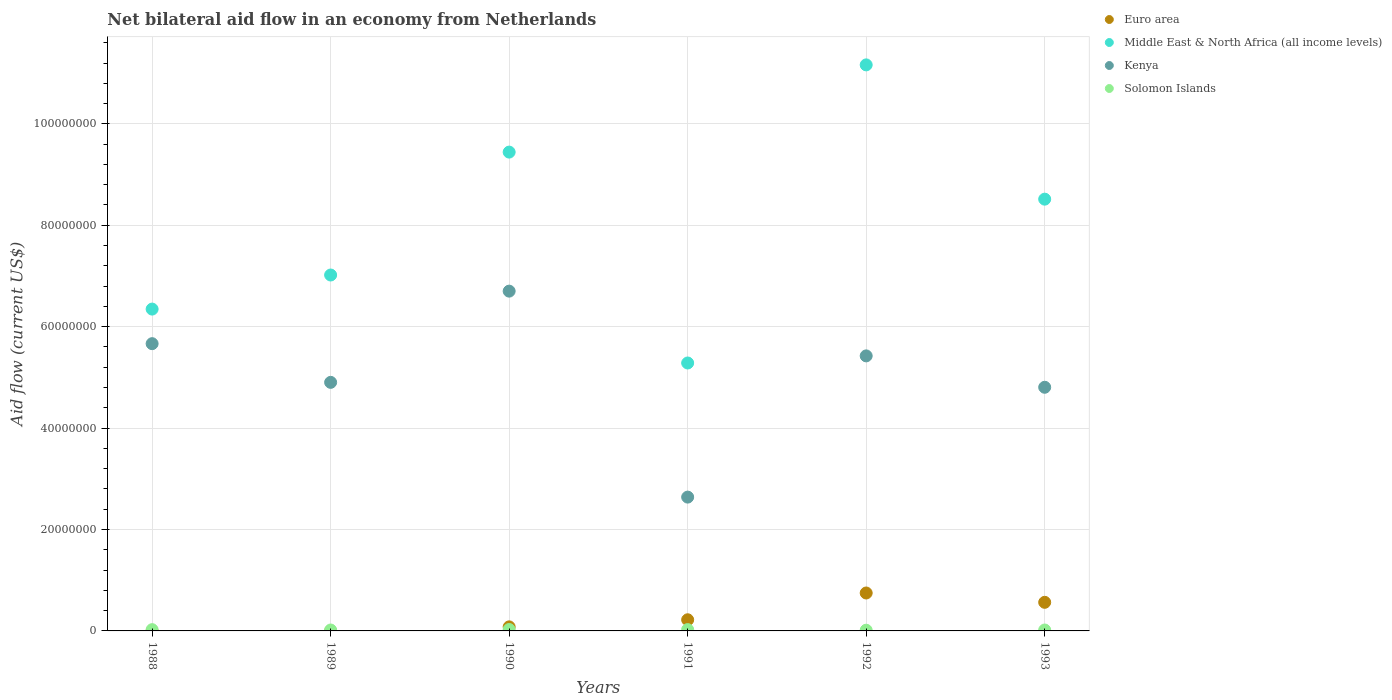How many different coloured dotlines are there?
Keep it short and to the point. 4. Is the number of dotlines equal to the number of legend labels?
Keep it short and to the point. No. What is the net bilateral aid flow in Euro area in 1993?
Provide a succinct answer. 5.64e+06. Across all years, what is the maximum net bilateral aid flow in Euro area?
Provide a short and direct response. 7.48e+06. Across all years, what is the minimum net bilateral aid flow in Kenya?
Give a very brief answer. 2.64e+07. In which year was the net bilateral aid flow in Solomon Islands maximum?
Your answer should be very brief. 1990. What is the total net bilateral aid flow in Kenya in the graph?
Keep it short and to the point. 3.01e+08. What is the difference between the net bilateral aid flow in Solomon Islands in 1990 and that in 1993?
Ensure brevity in your answer.  1.00e+05. What is the difference between the net bilateral aid flow in Kenya in 1992 and the net bilateral aid flow in Euro area in 1989?
Your answer should be compact. 5.42e+07. What is the average net bilateral aid flow in Euro area per year?
Your answer should be compact. 2.69e+06. In the year 1993, what is the difference between the net bilateral aid flow in Middle East & North Africa (all income levels) and net bilateral aid flow in Kenya?
Keep it short and to the point. 3.71e+07. What is the ratio of the net bilateral aid flow in Kenya in 1991 to that in 1993?
Your answer should be very brief. 0.55. Is the net bilateral aid flow in Middle East & North Africa (all income levels) in 1990 less than that in 1992?
Provide a succinct answer. Yes. What is the difference between the highest and the second highest net bilateral aid flow in Solomon Islands?
Make the answer very short. 2.00e+04. What is the difference between the highest and the lowest net bilateral aid flow in Middle East & North Africa (all income levels)?
Your answer should be compact. 5.88e+07. Is the sum of the net bilateral aid flow in Middle East & North Africa (all income levels) in 1989 and 1990 greater than the maximum net bilateral aid flow in Solomon Islands across all years?
Offer a terse response. Yes. Does the net bilateral aid flow in Kenya monotonically increase over the years?
Keep it short and to the point. No. Is the net bilateral aid flow in Kenya strictly greater than the net bilateral aid flow in Solomon Islands over the years?
Your answer should be very brief. Yes. Does the graph contain any zero values?
Your answer should be compact. Yes. Where does the legend appear in the graph?
Your answer should be very brief. Top right. How many legend labels are there?
Your response must be concise. 4. What is the title of the graph?
Your response must be concise. Net bilateral aid flow in an economy from Netherlands. Does "Tunisia" appear as one of the legend labels in the graph?
Keep it short and to the point. No. What is the label or title of the X-axis?
Keep it short and to the point. Years. What is the Aid flow (current US$) of Euro area in 1988?
Your response must be concise. 0. What is the Aid flow (current US$) of Middle East & North Africa (all income levels) in 1988?
Offer a terse response. 6.35e+07. What is the Aid flow (current US$) in Kenya in 1988?
Your response must be concise. 5.66e+07. What is the Aid flow (current US$) in Solomon Islands in 1988?
Keep it short and to the point. 2.50e+05. What is the Aid flow (current US$) in Euro area in 1989?
Provide a succinct answer. 0. What is the Aid flow (current US$) of Middle East & North Africa (all income levels) in 1989?
Give a very brief answer. 7.02e+07. What is the Aid flow (current US$) in Kenya in 1989?
Offer a terse response. 4.90e+07. What is the Aid flow (current US$) in Solomon Islands in 1989?
Provide a short and direct response. 1.80e+05. What is the Aid flow (current US$) of Euro area in 1990?
Your answer should be compact. 8.00e+05. What is the Aid flow (current US$) of Middle East & North Africa (all income levels) in 1990?
Make the answer very short. 9.44e+07. What is the Aid flow (current US$) of Kenya in 1990?
Your response must be concise. 6.70e+07. What is the Aid flow (current US$) in Solomon Islands in 1990?
Provide a succinct answer. 2.80e+05. What is the Aid flow (current US$) of Euro area in 1991?
Ensure brevity in your answer.  2.20e+06. What is the Aid flow (current US$) of Middle East & North Africa (all income levels) in 1991?
Offer a very short reply. 5.28e+07. What is the Aid flow (current US$) of Kenya in 1991?
Your answer should be compact. 2.64e+07. What is the Aid flow (current US$) in Euro area in 1992?
Keep it short and to the point. 7.48e+06. What is the Aid flow (current US$) of Middle East & North Africa (all income levels) in 1992?
Provide a succinct answer. 1.12e+08. What is the Aid flow (current US$) in Kenya in 1992?
Ensure brevity in your answer.  5.42e+07. What is the Aid flow (current US$) of Euro area in 1993?
Make the answer very short. 5.64e+06. What is the Aid flow (current US$) in Middle East & North Africa (all income levels) in 1993?
Offer a terse response. 8.52e+07. What is the Aid flow (current US$) in Kenya in 1993?
Make the answer very short. 4.80e+07. What is the Aid flow (current US$) in Solomon Islands in 1993?
Offer a very short reply. 1.80e+05. Across all years, what is the maximum Aid flow (current US$) of Euro area?
Provide a short and direct response. 7.48e+06. Across all years, what is the maximum Aid flow (current US$) in Middle East & North Africa (all income levels)?
Your answer should be compact. 1.12e+08. Across all years, what is the maximum Aid flow (current US$) of Kenya?
Make the answer very short. 6.70e+07. Across all years, what is the maximum Aid flow (current US$) of Solomon Islands?
Make the answer very short. 2.80e+05. Across all years, what is the minimum Aid flow (current US$) of Euro area?
Ensure brevity in your answer.  0. Across all years, what is the minimum Aid flow (current US$) of Middle East & North Africa (all income levels)?
Keep it short and to the point. 5.28e+07. Across all years, what is the minimum Aid flow (current US$) of Kenya?
Provide a short and direct response. 2.64e+07. Across all years, what is the minimum Aid flow (current US$) in Solomon Islands?
Your response must be concise. 1.40e+05. What is the total Aid flow (current US$) of Euro area in the graph?
Provide a short and direct response. 1.61e+07. What is the total Aid flow (current US$) in Middle East & North Africa (all income levels) in the graph?
Your response must be concise. 4.78e+08. What is the total Aid flow (current US$) in Kenya in the graph?
Give a very brief answer. 3.01e+08. What is the total Aid flow (current US$) of Solomon Islands in the graph?
Offer a very short reply. 1.29e+06. What is the difference between the Aid flow (current US$) in Middle East & North Africa (all income levels) in 1988 and that in 1989?
Your answer should be very brief. -6.72e+06. What is the difference between the Aid flow (current US$) in Kenya in 1988 and that in 1989?
Make the answer very short. 7.63e+06. What is the difference between the Aid flow (current US$) of Solomon Islands in 1988 and that in 1989?
Provide a short and direct response. 7.00e+04. What is the difference between the Aid flow (current US$) of Middle East & North Africa (all income levels) in 1988 and that in 1990?
Give a very brief answer. -3.10e+07. What is the difference between the Aid flow (current US$) of Kenya in 1988 and that in 1990?
Your answer should be very brief. -1.04e+07. What is the difference between the Aid flow (current US$) in Solomon Islands in 1988 and that in 1990?
Ensure brevity in your answer.  -3.00e+04. What is the difference between the Aid flow (current US$) in Middle East & North Africa (all income levels) in 1988 and that in 1991?
Give a very brief answer. 1.06e+07. What is the difference between the Aid flow (current US$) in Kenya in 1988 and that in 1991?
Provide a short and direct response. 3.03e+07. What is the difference between the Aid flow (current US$) of Middle East & North Africa (all income levels) in 1988 and that in 1992?
Offer a terse response. -4.82e+07. What is the difference between the Aid flow (current US$) of Kenya in 1988 and that in 1992?
Your response must be concise. 2.41e+06. What is the difference between the Aid flow (current US$) of Middle East & North Africa (all income levels) in 1988 and that in 1993?
Your answer should be compact. -2.17e+07. What is the difference between the Aid flow (current US$) in Kenya in 1988 and that in 1993?
Keep it short and to the point. 8.60e+06. What is the difference between the Aid flow (current US$) of Middle East & North Africa (all income levels) in 1989 and that in 1990?
Your response must be concise. -2.42e+07. What is the difference between the Aid flow (current US$) in Kenya in 1989 and that in 1990?
Make the answer very short. -1.80e+07. What is the difference between the Aid flow (current US$) in Middle East & North Africa (all income levels) in 1989 and that in 1991?
Provide a short and direct response. 1.74e+07. What is the difference between the Aid flow (current US$) of Kenya in 1989 and that in 1991?
Provide a short and direct response. 2.26e+07. What is the difference between the Aid flow (current US$) in Solomon Islands in 1989 and that in 1991?
Give a very brief answer. -8.00e+04. What is the difference between the Aid flow (current US$) of Middle East & North Africa (all income levels) in 1989 and that in 1992?
Your answer should be compact. -4.14e+07. What is the difference between the Aid flow (current US$) in Kenya in 1989 and that in 1992?
Ensure brevity in your answer.  -5.22e+06. What is the difference between the Aid flow (current US$) in Solomon Islands in 1989 and that in 1992?
Offer a very short reply. 4.00e+04. What is the difference between the Aid flow (current US$) of Middle East & North Africa (all income levels) in 1989 and that in 1993?
Offer a terse response. -1.50e+07. What is the difference between the Aid flow (current US$) in Kenya in 1989 and that in 1993?
Keep it short and to the point. 9.70e+05. What is the difference between the Aid flow (current US$) of Euro area in 1990 and that in 1991?
Offer a terse response. -1.40e+06. What is the difference between the Aid flow (current US$) in Middle East & North Africa (all income levels) in 1990 and that in 1991?
Make the answer very short. 4.16e+07. What is the difference between the Aid flow (current US$) of Kenya in 1990 and that in 1991?
Your answer should be compact. 4.06e+07. What is the difference between the Aid flow (current US$) in Euro area in 1990 and that in 1992?
Keep it short and to the point. -6.68e+06. What is the difference between the Aid flow (current US$) in Middle East & North Africa (all income levels) in 1990 and that in 1992?
Make the answer very short. -1.72e+07. What is the difference between the Aid flow (current US$) of Kenya in 1990 and that in 1992?
Provide a succinct answer. 1.28e+07. What is the difference between the Aid flow (current US$) of Solomon Islands in 1990 and that in 1992?
Ensure brevity in your answer.  1.40e+05. What is the difference between the Aid flow (current US$) in Euro area in 1990 and that in 1993?
Your response must be concise. -4.84e+06. What is the difference between the Aid flow (current US$) in Middle East & North Africa (all income levels) in 1990 and that in 1993?
Your answer should be very brief. 9.28e+06. What is the difference between the Aid flow (current US$) of Kenya in 1990 and that in 1993?
Your response must be concise. 1.90e+07. What is the difference between the Aid flow (current US$) in Solomon Islands in 1990 and that in 1993?
Provide a succinct answer. 1.00e+05. What is the difference between the Aid flow (current US$) of Euro area in 1991 and that in 1992?
Provide a succinct answer. -5.28e+06. What is the difference between the Aid flow (current US$) of Middle East & North Africa (all income levels) in 1991 and that in 1992?
Give a very brief answer. -5.88e+07. What is the difference between the Aid flow (current US$) in Kenya in 1991 and that in 1992?
Make the answer very short. -2.78e+07. What is the difference between the Aid flow (current US$) in Solomon Islands in 1991 and that in 1992?
Offer a terse response. 1.20e+05. What is the difference between the Aid flow (current US$) of Euro area in 1991 and that in 1993?
Keep it short and to the point. -3.44e+06. What is the difference between the Aid flow (current US$) of Middle East & North Africa (all income levels) in 1991 and that in 1993?
Offer a very short reply. -3.23e+07. What is the difference between the Aid flow (current US$) of Kenya in 1991 and that in 1993?
Offer a very short reply. -2.17e+07. What is the difference between the Aid flow (current US$) in Solomon Islands in 1991 and that in 1993?
Your response must be concise. 8.00e+04. What is the difference between the Aid flow (current US$) of Euro area in 1992 and that in 1993?
Give a very brief answer. 1.84e+06. What is the difference between the Aid flow (current US$) of Middle East & North Africa (all income levels) in 1992 and that in 1993?
Provide a short and direct response. 2.65e+07. What is the difference between the Aid flow (current US$) of Kenya in 1992 and that in 1993?
Ensure brevity in your answer.  6.19e+06. What is the difference between the Aid flow (current US$) of Middle East & North Africa (all income levels) in 1988 and the Aid flow (current US$) of Kenya in 1989?
Keep it short and to the point. 1.44e+07. What is the difference between the Aid flow (current US$) in Middle East & North Africa (all income levels) in 1988 and the Aid flow (current US$) in Solomon Islands in 1989?
Your response must be concise. 6.33e+07. What is the difference between the Aid flow (current US$) of Kenya in 1988 and the Aid flow (current US$) of Solomon Islands in 1989?
Your response must be concise. 5.65e+07. What is the difference between the Aid flow (current US$) of Middle East & North Africa (all income levels) in 1988 and the Aid flow (current US$) of Kenya in 1990?
Your answer should be very brief. -3.54e+06. What is the difference between the Aid flow (current US$) of Middle East & North Africa (all income levels) in 1988 and the Aid flow (current US$) of Solomon Islands in 1990?
Make the answer very short. 6.32e+07. What is the difference between the Aid flow (current US$) in Kenya in 1988 and the Aid flow (current US$) in Solomon Islands in 1990?
Provide a short and direct response. 5.64e+07. What is the difference between the Aid flow (current US$) of Middle East & North Africa (all income levels) in 1988 and the Aid flow (current US$) of Kenya in 1991?
Make the answer very short. 3.71e+07. What is the difference between the Aid flow (current US$) of Middle East & North Africa (all income levels) in 1988 and the Aid flow (current US$) of Solomon Islands in 1991?
Make the answer very short. 6.32e+07. What is the difference between the Aid flow (current US$) in Kenya in 1988 and the Aid flow (current US$) in Solomon Islands in 1991?
Your answer should be compact. 5.64e+07. What is the difference between the Aid flow (current US$) in Middle East & North Africa (all income levels) in 1988 and the Aid flow (current US$) in Kenya in 1992?
Your answer should be very brief. 9.23e+06. What is the difference between the Aid flow (current US$) in Middle East & North Africa (all income levels) in 1988 and the Aid flow (current US$) in Solomon Islands in 1992?
Offer a very short reply. 6.33e+07. What is the difference between the Aid flow (current US$) of Kenya in 1988 and the Aid flow (current US$) of Solomon Islands in 1992?
Provide a succinct answer. 5.65e+07. What is the difference between the Aid flow (current US$) of Middle East & North Africa (all income levels) in 1988 and the Aid flow (current US$) of Kenya in 1993?
Your answer should be very brief. 1.54e+07. What is the difference between the Aid flow (current US$) of Middle East & North Africa (all income levels) in 1988 and the Aid flow (current US$) of Solomon Islands in 1993?
Provide a short and direct response. 6.33e+07. What is the difference between the Aid flow (current US$) of Kenya in 1988 and the Aid flow (current US$) of Solomon Islands in 1993?
Your response must be concise. 5.65e+07. What is the difference between the Aid flow (current US$) in Middle East & North Africa (all income levels) in 1989 and the Aid flow (current US$) in Kenya in 1990?
Keep it short and to the point. 3.18e+06. What is the difference between the Aid flow (current US$) in Middle East & North Africa (all income levels) in 1989 and the Aid flow (current US$) in Solomon Islands in 1990?
Make the answer very short. 6.99e+07. What is the difference between the Aid flow (current US$) in Kenya in 1989 and the Aid flow (current US$) in Solomon Islands in 1990?
Ensure brevity in your answer.  4.87e+07. What is the difference between the Aid flow (current US$) of Middle East & North Africa (all income levels) in 1989 and the Aid flow (current US$) of Kenya in 1991?
Your response must be concise. 4.38e+07. What is the difference between the Aid flow (current US$) in Middle East & North Africa (all income levels) in 1989 and the Aid flow (current US$) in Solomon Islands in 1991?
Keep it short and to the point. 6.99e+07. What is the difference between the Aid flow (current US$) of Kenya in 1989 and the Aid flow (current US$) of Solomon Islands in 1991?
Your answer should be very brief. 4.88e+07. What is the difference between the Aid flow (current US$) of Middle East & North Africa (all income levels) in 1989 and the Aid flow (current US$) of Kenya in 1992?
Keep it short and to the point. 1.60e+07. What is the difference between the Aid flow (current US$) in Middle East & North Africa (all income levels) in 1989 and the Aid flow (current US$) in Solomon Islands in 1992?
Make the answer very short. 7.00e+07. What is the difference between the Aid flow (current US$) in Kenya in 1989 and the Aid flow (current US$) in Solomon Islands in 1992?
Make the answer very short. 4.89e+07. What is the difference between the Aid flow (current US$) in Middle East & North Africa (all income levels) in 1989 and the Aid flow (current US$) in Kenya in 1993?
Offer a terse response. 2.21e+07. What is the difference between the Aid flow (current US$) of Middle East & North Africa (all income levels) in 1989 and the Aid flow (current US$) of Solomon Islands in 1993?
Your answer should be very brief. 7.00e+07. What is the difference between the Aid flow (current US$) of Kenya in 1989 and the Aid flow (current US$) of Solomon Islands in 1993?
Give a very brief answer. 4.88e+07. What is the difference between the Aid flow (current US$) of Euro area in 1990 and the Aid flow (current US$) of Middle East & North Africa (all income levels) in 1991?
Ensure brevity in your answer.  -5.20e+07. What is the difference between the Aid flow (current US$) of Euro area in 1990 and the Aid flow (current US$) of Kenya in 1991?
Make the answer very short. -2.56e+07. What is the difference between the Aid flow (current US$) in Euro area in 1990 and the Aid flow (current US$) in Solomon Islands in 1991?
Your response must be concise. 5.40e+05. What is the difference between the Aid flow (current US$) in Middle East & North Africa (all income levels) in 1990 and the Aid flow (current US$) in Kenya in 1991?
Your answer should be compact. 6.80e+07. What is the difference between the Aid flow (current US$) of Middle East & North Africa (all income levels) in 1990 and the Aid flow (current US$) of Solomon Islands in 1991?
Ensure brevity in your answer.  9.42e+07. What is the difference between the Aid flow (current US$) of Kenya in 1990 and the Aid flow (current US$) of Solomon Islands in 1991?
Make the answer very short. 6.68e+07. What is the difference between the Aid flow (current US$) of Euro area in 1990 and the Aid flow (current US$) of Middle East & North Africa (all income levels) in 1992?
Offer a very short reply. -1.11e+08. What is the difference between the Aid flow (current US$) in Euro area in 1990 and the Aid flow (current US$) in Kenya in 1992?
Provide a succinct answer. -5.34e+07. What is the difference between the Aid flow (current US$) in Euro area in 1990 and the Aid flow (current US$) in Solomon Islands in 1992?
Ensure brevity in your answer.  6.60e+05. What is the difference between the Aid flow (current US$) of Middle East & North Africa (all income levels) in 1990 and the Aid flow (current US$) of Kenya in 1992?
Make the answer very short. 4.02e+07. What is the difference between the Aid flow (current US$) in Middle East & North Africa (all income levels) in 1990 and the Aid flow (current US$) in Solomon Islands in 1992?
Your answer should be compact. 9.43e+07. What is the difference between the Aid flow (current US$) in Kenya in 1990 and the Aid flow (current US$) in Solomon Islands in 1992?
Make the answer very short. 6.69e+07. What is the difference between the Aid flow (current US$) in Euro area in 1990 and the Aid flow (current US$) in Middle East & North Africa (all income levels) in 1993?
Offer a terse response. -8.44e+07. What is the difference between the Aid flow (current US$) of Euro area in 1990 and the Aid flow (current US$) of Kenya in 1993?
Ensure brevity in your answer.  -4.72e+07. What is the difference between the Aid flow (current US$) in Euro area in 1990 and the Aid flow (current US$) in Solomon Islands in 1993?
Provide a short and direct response. 6.20e+05. What is the difference between the Aid flow (current US$) in Middle East & North Africa (all income levels) in 1990 and the Aid flow (current US$) in Kenya in 1993?
Provide a succinct answer. 4.64e+07. What is the difference between the Aid flow (current US$) in Middle East & North Africa (all income levels) in 1990 and the Aid flow (current US$) in Solomon Islands in 1993?
Your answer should be compact. 9.42e+07. What is the difference between the Aid flow (current US$) of Kenya in 1990 and the Aid flow (current US$) of Solomon Islands in 1993?
Ensure brevity in your answer.  6.68e+07. What is the difference between the Aid flow (current US$) of Euro area in 1991 and the Aid flow (current US$) of Middle East & North Africa (all income levels) in 1992?
Provide a short and direct response. -1.09e+08. What is the difference between the Aid flow (current US$) in Euro area in 1991 and the Aid flow (current US$) in Kenya in 1992?
Ensure brevity in your answer.  -5.20e+07. What is the difference between the Aid flow (current US$) of Euro area in 1991 and the Aid flow (current US$) of Solomon Islands in 1992?
Your answer should be very brief. 2.06e+06. What is the difference between the Aid flow (current US$) of Middle East & North Africa (all income levels) in 1991 and the Aid flow (current US$) of Kenya in 1992?
Provide a short and direct response. -1.40e+06. What is the difference between the Aid flow (current US$) of Middle East & North Africa (all income levels) in 1991 and the Aid flow (current US$) of Solomon Islands in 1992?
Your response must be concise. 5.27e+07. What is the difference between the Aid flow (current US$) in Kenya in 1991 and the Aid flow (current US$) in Solomon Islands in 1992?
Give a very brief answer. 2.62e+07. What is the difference between the Aid flow (current US$) of Euro area in 1991 and the Aid flow (current US$) of Middle East & North Africa (all income levels) in 1993?
Offer a very short reply. -8.30e+07. What is the difference between the Aid flow (current US$) in Euro area in 1991 and the Aid flow (current US$) in Kenya in 1993?
Provide a succinct answer. -4.58e+07. What is the difference between the Aid flow (current US$) in Euro area in 1991 and the Aid flow (current US$) in Solomon Islands in 1993?
Provide a succinct answer. 2.02e+06. What is the difference between the Aid flow (current US$) in Middle East & North Africa (all income levels) in 1991 and the Aid flow (current US$) in Kenya in 1993?
Ensure brevity in your answer.  4.79e+06. What is the difference between the Aid flow (current US$) in Middle East & North Africa (all income levels) in 1991 and the Aid flow (current US$) in Solomon Islands in 1993?
Provide a succinct answer. 5.27e+07. What is the difference between the Aid flow (current US$) in Kenya in 1991 and the Aid flow (current US$) in Solomon Islands in 1993?
Provide a succinct answer. 2.62e+07. What is the difference between the Aid flow (current US$) of Euro area in 1992 and the Aid flow (current US$) of Middle East & North Africa (all income levels) in 1993?
Offer a terse response. -7.77e+07. What is the difference between the Aid flow (current US$) in Euro area in 1992 and the Aid flow (current US$) in Kenya in 1993?
Your answer should be compact. -4.06e+07. What is the difference between the Aid flow (current US$) of Euro area in 1992 and the Aid flow (current US$) of Solomon Islands in 1993?
Ensure brevity in your answer.  7.30e+06. What is the difference between the Aid flow (current US$) in Middle East & North Africa (all income levels) in 1992 and the Aid flow (current US$) in Kenya in 1993?
Make the answer very short. 6.36e+07. What is the difference between the Aid flow (current US$) in Middle East & North Africa (all income levels) in 1992 and the Aid flow (current US$) in Solomon Islands in 1993?
Ensure brevity in your answer.  1.11e+08. What is the difference between the Aid flow (current US$) in Kenya in 1992 and the Aid flow (current US$) in Solomon Islands in 1993?
Keep it short and to the point. 5.41e+07. What is the average Aid flow (current US$) in Euro area per year?
Give a very brief answer. 2.69e+06. What is the average Aid flow (current US$) in Middle East & North Africa (all income levels) per year?
Provide a short and direct response. 7.96e+07. What is the average Aid flow (current US$) of Kenya per year?
Your answer should be compact. 5.02e+07. What is the average Aid flow (current US$) of Solomon Islands per year?
Ensure brevity in your answer.  2.15e+05. In the year 1988, what is the difference between the Aid flow (current US$) in Middle East & North Africa (all income levels) and Aid flow (current US$) in Kenya?
Provide a short and direct response. 6.82e+06. In the year 1988, what is the difference between the Aid flow (current US$) in Middle East & North Africa (all income levels) and Aid flow (current US$) in Solomon Islands?
Provide a short and direct response. 6.32e+07. In the year 1988, what is the difference between the Aid flow (current US$) in Kenya and Aid flow (current US$) in Solomon Islands?
Your answer should be very brief. 5.64e+07. In the year 1989, what is the difference between the Aid flow (current US$) in Middle East & North Africa (all income levels) and Aid flow (current US$) in Kenya?
Offer a very short reply. 2.12e+07. In the year 1989, what is the difference between the Aid flow (current US$) in Middle East & North Africa (all income levels) and Aid flow (current US$) in Solomon Islands?
Make the answer very short. 7.00e+07. In the year 1989, what is the difference between the Aid flow (current US$) in Kenya and Aid flow (current US$) in Solomon Islands?
Your response must be concise. 4.88e+07. In the year 1990, what is the difference between the Aid flow (current US$) in Euro area and Aid flow (current US$) in Middle East & North Africa (all income levels)?
Provide a succinct answer. -9.36e+07. In the year 1990, what is the difference between the Aid flow (current US$) of Euro area and Aid flow (current US$) of Kenya?
Keep it short and to the point. -6.62e+07. In the year 1990, what is the difference between the Aid flow (current US$) of Euro area and Aid flow (current US$) of Solomon Islands?
Provide a succinct answer. 5.20e+05. In the year 1990, what is the difference between the Aid flow (current US$) of Middle East & North Africa (all income levels) and Aid flow (current US$) of Kenya?
Your answer should be very brief. 2.74e+07. In the year 1990, what is the difference between the Aid flow (current US$) of Middle East & North Africa (all income levels) and Aid flow (current US$) of Solomon Islands?
Your answer should be very brief. 9.42e+07. In the year 1990, what is the difference between the Aid flow (current US$) of Kenya and Aid flow (current US$) of Solomon Islands?
Give a very brief answer. 6.67e+07. In the year 1991, what is the difference between the Aid flow (current US$) of Euro area and Aid flow (current US$) of Middle East & North Africa (all income levels)?
Offer a very short reply. -5.06e+07. In the year 1991, what is the difference between the Aid flow (current US$) of Euro area and Aid flow (current US$) of Kenya?
Offer a terse response. -2.42e+07. In the year 1991, what is the difference between the Aid flow (current US$) in Euro area and Aid flow (current US$) in Solomon Islands?
Your answer should be compact. 1.94e+06. In the year 1991, what is the difference between the Aid flow (current US$) in Middle East & North Africa (all income levels) and Aid flow (current US$) in Kenya?
Your response must be concise. 2.64e+07. In the year 1991, what is the difference between the Aid flow (current US$) in Middle East & North Africa (all income levels) and Aid flow (current US$) in Solomon Islands?
Ensure brevity in your answer.  5.26e+07. In the year 1991, what is the difference between the Aid flow (current US$) of Kenya and Aid flow (current US$) of Solomon Islands?
Keep it short and to the point. 2.61e+07. In the year 1992, what is the difference between the Aid flow (current US$) in Euro area and Aid flow (current US$) in Middle East & North Africa (all income levels)?
Offer a terse response. -1.04e+08. In the year 1992, what is the difference between the Aid flow (current US$) in Euro area and Aid flow (current US$) in Kenya?
Offer a terse response. -4.68e+07. In the year 1992, what is the difference between the Aid flow (current US$) in Euro area and Aid flow (current US$) in Solomon Islands?
Your response must be concise. 7.34e+06. In the year 1992, what is the difference between the Aid flow (current US$) of Middle East & North Africa (all income levels) and Aid flow (current US$) of Kenya?
Give a very brief answer. 5.74e+07. In the year 1992, what is the difference between the Aid flow (current US$) of Middle East & North Africa (all income levels) and Aid flow (current US$) of Solomon Islands?
Provide a short and direct response. 1.11e+08. In the year 1992, what is the difference between the Aid flow (current US$) of Kenya and Aid flow (current US$) of Solomon Islands?
Your answer should be very brief. 5.41e+07. In the year 1993, what is the difference between the Aid flow (current US$) of Euro area and Aid flow (current US$) of Middle East & North Africa (all income levels)?
Keep it short and to the point. -7.95e+07. In the year 1993, what is the difference between the Aid flow (current US$) in Euro area and Aid flow (current US$) in Kenya?
Your answer should be very brief. -4.24e+07. In the year 1993, what is the difference between the Aid flow (current US$) of Euro area and Aid flow (current US$) of Solomon Islands?
Your response must be concise. 5.46e+06. In the year 1993, what is the difference between the Aid flow (current US$) in Middle East & North Africa (all income levels) and Aid flow (current US$) in Kenya?
Offer a very short reply. 3.71e+07. In the year 1993, what is the difference between the Aid flow (current US$) in Middle East & North Africa (all income levels) and Aid flow (current US$) in Solomon Islands?
Offer a very short reply. 8.50e+07. In the year 1993, what is the difference between the Aid flow (current US$) of Kenya and Aid flow (current US$) of Solomon Islands?
Provide a succinct answer. 4.79e+07. What is the ratio of the Aid flow (current US$) in Middle East & North Africa (all income levels) in 1988 to that in 1989?
Your answer should be very brief. 0.9. What is the ratio of the Aid flow (current US$) in Kenya in 1988 to that in 1989?
Ensure brevity in your answer.  1.16. What is the ratio of the Aid flow (current US$) of Solomon Islands in 1988 to that in 1989?
Your answer should be very brief. 1.39. What is the ratio of the Aid flow (current US$) of Middle East & North Africa (all income levels) in 1988 to that in 1990?
Your answer should be very brief. 0.67. What is the ratio of the Aid flow (current US$) in Kenya in 1988 to that in 1990?
Your response must be concise. 0.85. What is the ratio of the Aid flow (current US$) of Solomon Islands in 1988 to that in 1990?
Make the answer very short. 0.89. What is the ratio of the Aid flow (current US$) of Middle East & North Africa (all income levels) in 1988 to that in 1991?
Your answer should be very brief. 1.2. What is the ratio of the Aid flow (current US$) in Kenya in 1988 to that in 1991?
Your response must be concise. 2.15. What is the ratio of the Aid flow (current US$) of Solomon Islands in 1988 to that in 1991?
Make the answer very short. 0.96. What is the ratio of the Aid flow (current US$) of Middle East & North Africa (all income levels) in 1988 to that in 1992?
Ensure brevity in your answer.  0.57. What is the ratio of the Aid flow (current US$) of Kenya in 1988 to that in 1992?
Your response must be concise. 1.04. What is the ratio of the Aid flow (current US$) of Solomon Islands in 1988 to that in 1992?
Provide a succinct answer. 1.79. What is the ratio of the Aid flow (current US$) of Middle East & North Africa (all income levels) in 1988 to that in 1993?
Your answer should be compact. 0.75. What is the ratio of the Aid flow (current US$) in Kenya in 1988 to that in 1993?
Offer a terse response. 1.18. What is the ratio of the Aid flow (current US$) in Solomon Islands in 1988 to that in 1993?
Your answer should be compact. 1.39. What is the ratio of the Aid flow (current US$) of Middle East & North Africa (all income levels) in 1989 to that in 1990?
Give a very brief answer. 0.74. What is the ratio of the Aid flow (current US$) of Kenya in 1989 to that in 1990?
Your answer should be very brief. 0.73. What is the ratio of the Aid flow (current US$) in Solomon Islands in 1989 to that in 1990?
Offer a very short reply. 0.64. What is the ratio of the Aid flow (current US$) in Middle East & North Africa (all income levels) in 1989 to that in 1991?
Give a very brief answer. 1.33. What is the ratio of the Aid flow (current US$) of Kenya in 1989 to that in 1991?
Make the answer very short. 1.86. What is the ratio of the Aid flow (current US$) of Solomon Islands in 1989 to that in 1991?
Provide a succinct answer. 0.69. What is the ratio of the Aid flow (current US$) in Middle East & North Africa (all income levels) in 1989 to that in 1992?
Provide a short and direct response. 0.63. What is the ratio of the Aid flow (current US$) in Kenya in 1989 to that in 1992?
Give a very brief answer. 0.9. What is the ratio of the Aid flow (current US$) in Solomon Islands in 1989 to that in 1992?
Your response must be concise. 1.29. What is the ratio of the Aid flow (current US$) in Middle East & North Africa (all income levels) in 1989 to that in 1993?
Keep it short and to the point. 0.82. What is the ratio of the Aid flow (current US$) of Kenya in 1989 to that in 1993?
Your answer should be very brief. 1.02. What is the ratio of the Aid flow (current US$) of Euro area in 1990 to that in 1991?
Provide a short and direct response. 0.36. What is the ratio of the Aid flow (current US$) of Middle East & North Africa (all income levels) in 1990 to that in 1991?
Offer a very short reply. 1.79. What is the ratio of the Aid flow (current US$) of Kenya in 1990 to that in 1991?
Offer a terse response. 2.54. What is the ratio of the Aid flow (current US$) of Euro area in 1990 to that in 1992?
Your answer should be very brief. 0.11. What is the ratio of the Aid flow (current US$) in Middle East & North Africa (all income levels) in 1990 to that in 1992?
Offer a terse response. 0.85. What is the ratio of the Aid flow (current US$) in Kenya in 1990 to that in 1992?
Your answer should be compact. 1.24. What is the ratio of the Aid flow (current US$) of Euro area in 1990 to that in 1993?
Give a very brief answer. 0.14. What is the ratio of the Aid flow (current US$) in Middle East & North Africa (all income levels) in 1990 to that in 1993?
Give a very brief answer. 1.11. What is the ratio of the Aid flow (current US$) in Kenya in 1990 to that in 1993?
Your answer should be very brief. 1.39. What is the ratio of the Aid flow (current US$) of Solomon Islands in 1990 to that in 1993?
Your answer should be very brief. 1.56. What is the ratio of the Aid flow (current US$) of Euro area in 1991 to that in 1992?
Your answer should be compact. 0.29. What is the ratio of the Aid flow (current US$) in Middle East & North Africa (all income levels) in 1991 to that in 1992?
Offer a terse response. 0.47. What is the ratio of the Aid flow (current US$) in Kenya in 1991 to that in 1992?
Your response must be concise. 0.49. What is the ratio of the Aid flow (current US$) in Solomon Islands in 1991 to that in 1992?
Your answer should be compact. 1.86. What is the ratio of the Aid flow (current US$) of Euro area in 1991 to that in 1993?
Provide a short and direct response. 0.39. What is the ratio of the Aid flow (current US$) in Middle East & North Africa (all income levels) in 1991 to that in 1993?
Offer a terse response. 0.62. What is the ratio of the Aid flow (current US$) of Kenya in 1991 to that in 1993?
Provide a short and direct response. 0.55. What is the ratio of the Aid flow (current US$) of Solomon Islands in 1991 to that in 1993?
Your answer should be very brief. 1.44. What is the ratio of the Aid flow (current US$) of Euro area in 1992 to that in 1993?
Your response must be concise. 1.33. What is the ratio of the Aid flow (current US$) in Middle East & North Africa (all income levels) in 1992 to that in 1993?
Offer a very short reply. 1.31. What is the ratio of the Aid flow (current US$) in Kenya in 1992 to that in 1993?
Provide a short and direct response. 1.13. What is the difference between the highest and the second highest Aid flow (current US$) in Euro area?
Your answer should be compact. 1.84e+06. What is the difference between the highest and the second highest Aid flow (current US$) of Middle East & North Africa (all income levels)?
Give a very brief answer. 1.72e+07. What is the difference between the highest and the second highest Aid flow (current US$) in Kenya?
Provide a succinct answer. 1.04e+07. What is the difference between the highest and the lowest Aid flow (current US$) of Euro area?
Offer a very short reply. 7.48e+06. What is the difference between the highest and the lowest Aid flow (current US$) of Middle East & North Africa (all income levels)?
Keep it short and to the point. 5.88e+07. What is the difference between the highest and the lowest Aid flow (current US$) in Kenya?
Offer a terse response. 4.06e+07. 